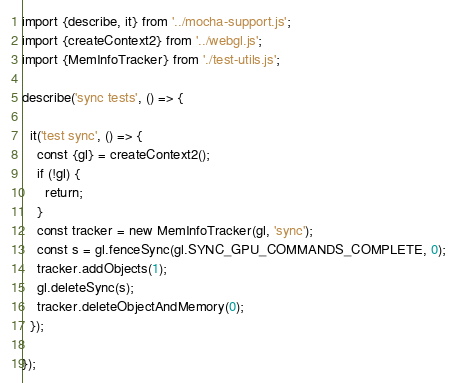<code> <loc_0><loc_0><loc_500><loc_500><_JavaScript_>import {describe, it} from '../mocha-support.js';
import {createContext2} from '../webgl.js';
import {MemInfoTracker} from './test-utils.js';

describe('sync tests', () => {

  it('test sync', () => {
    const {gl} = createContext2();
    if (!gl) {
      return;
    }
    const tracker = new MemInfoTracker(gl, 'sync');
    const s = gl.fenceSync(gl.SYNC_GPU_COMMANDS_COMPLETE, 0);
    tracker.addObjects(1);
    gl.deleteSync(s);
    tracker.deleteObjectAndMemory(0);
  });

});</code> 